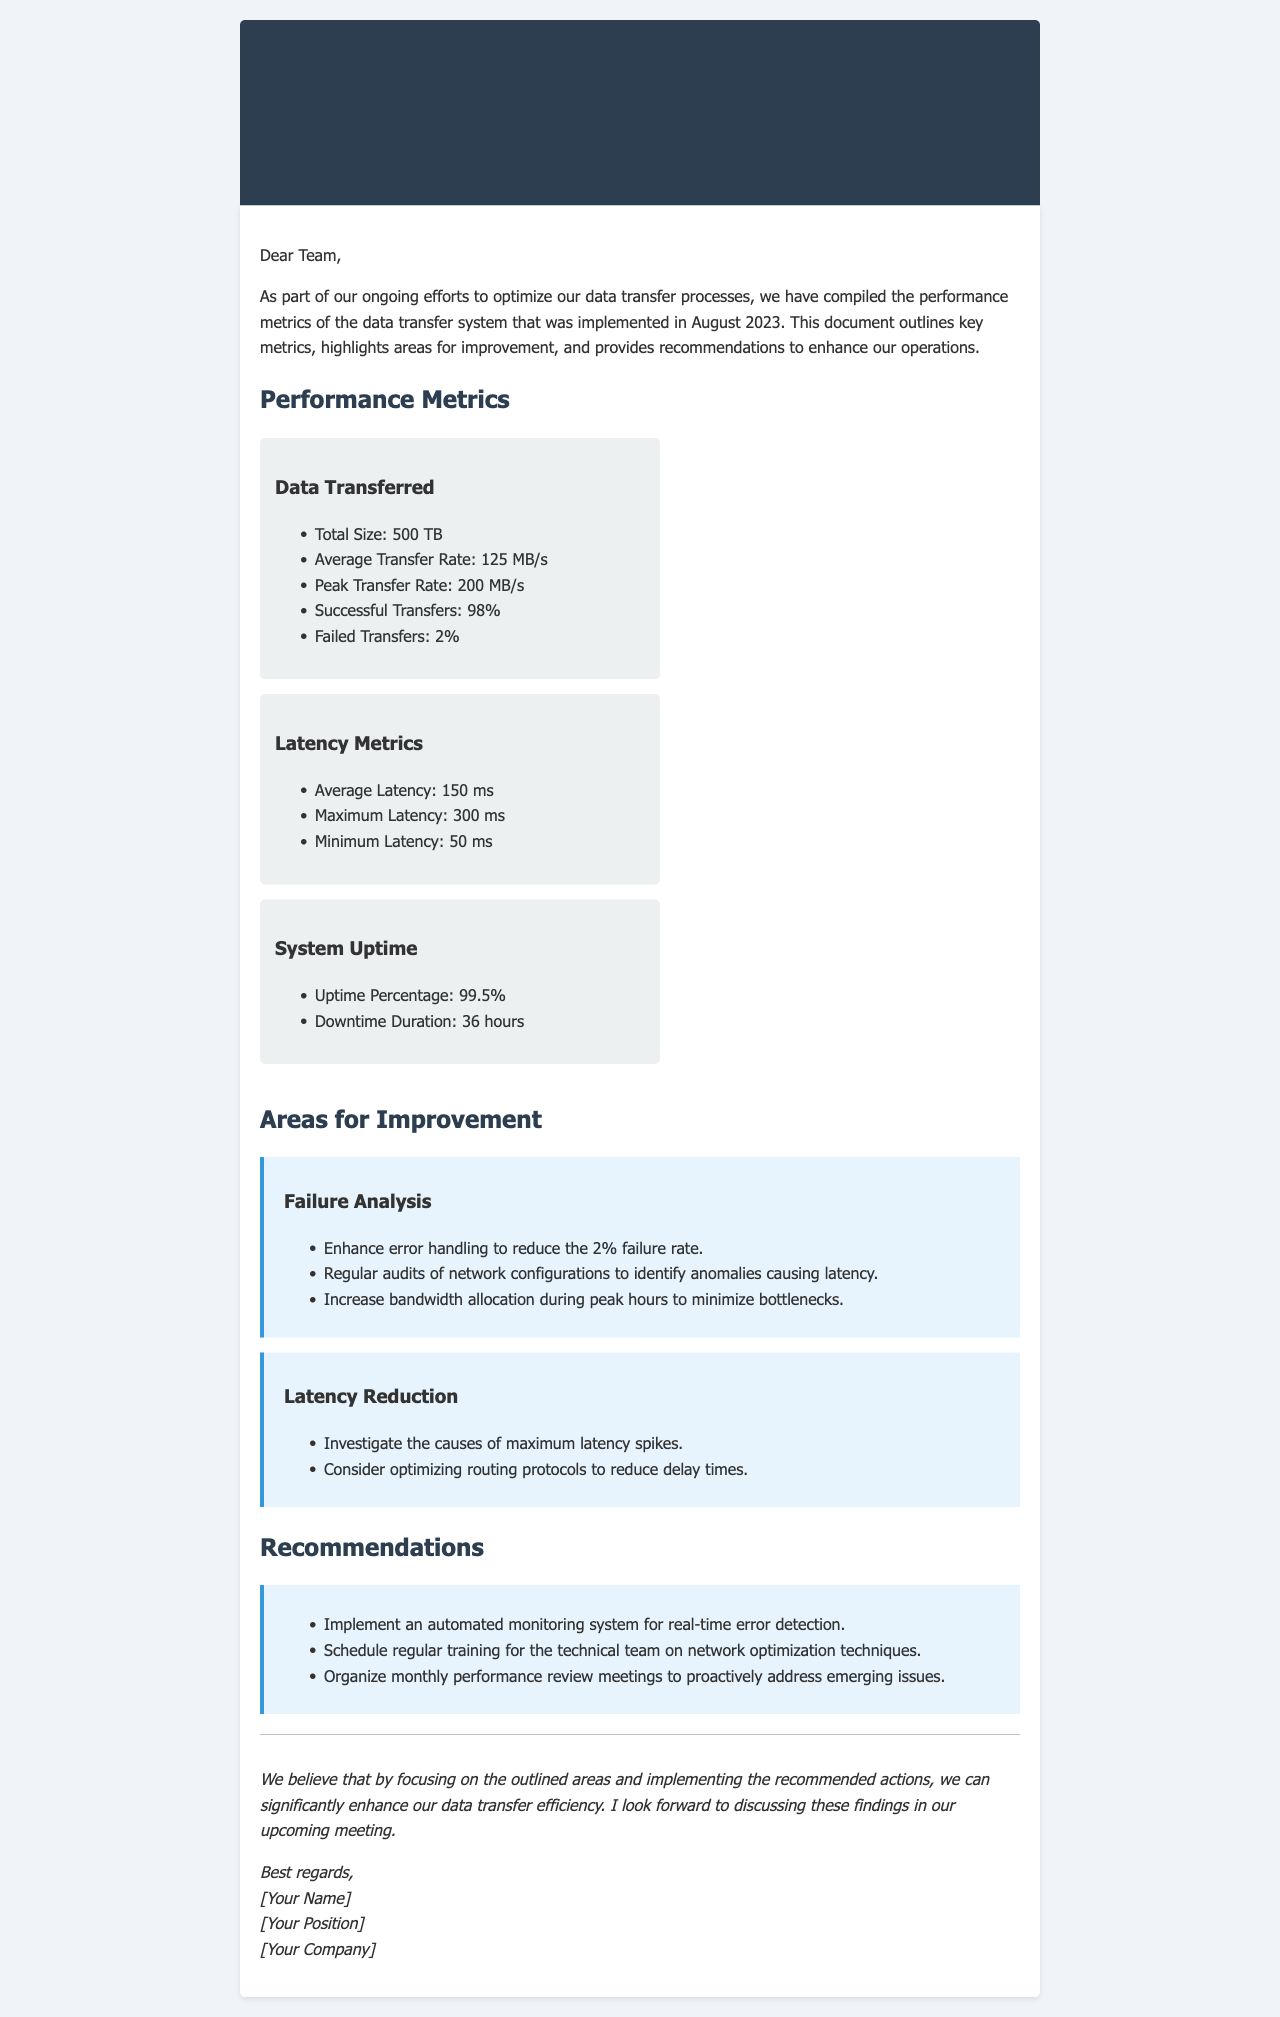What is the total size of data transferred? The total size of data transferred is mentioned in the metrics section of the document.
Answer: 500 TB What was the average transfer rate? The average transfer rate can be found in the performance metrics listed.
Answer: 125 MB/s What was the uptime percentage of the system? Uptime percentage is provided in the system uptime metrics section.
Answer: 99.5% What caused the maximum latency spikes? The document suggests investigating the causes of maximum latency spikes as an area for improvement.
Answer: Investigate causes What is the percentage of successful transfers? The percentage of successful transfers can be retrieved from the performance metrics.
Answer: 98% What should be scheduled regularly for the technical team? The recommendations section outlines what should be scheduled for the technical team.
Answer: Regular training How many hours did the system experience downtime? Downtime duration is specified in the system uptime metrics section of the document.
Answer: 36 hours What is a recommended action to enhance data transfer efficiency? The recommendations section provides various actions to enhance data transfer efficiency.
Answer: Implement automated monitoring What is the minimum latency recorded? The minimum latency is part of the latency metrics provided in the document.
Answer: 50 ms 